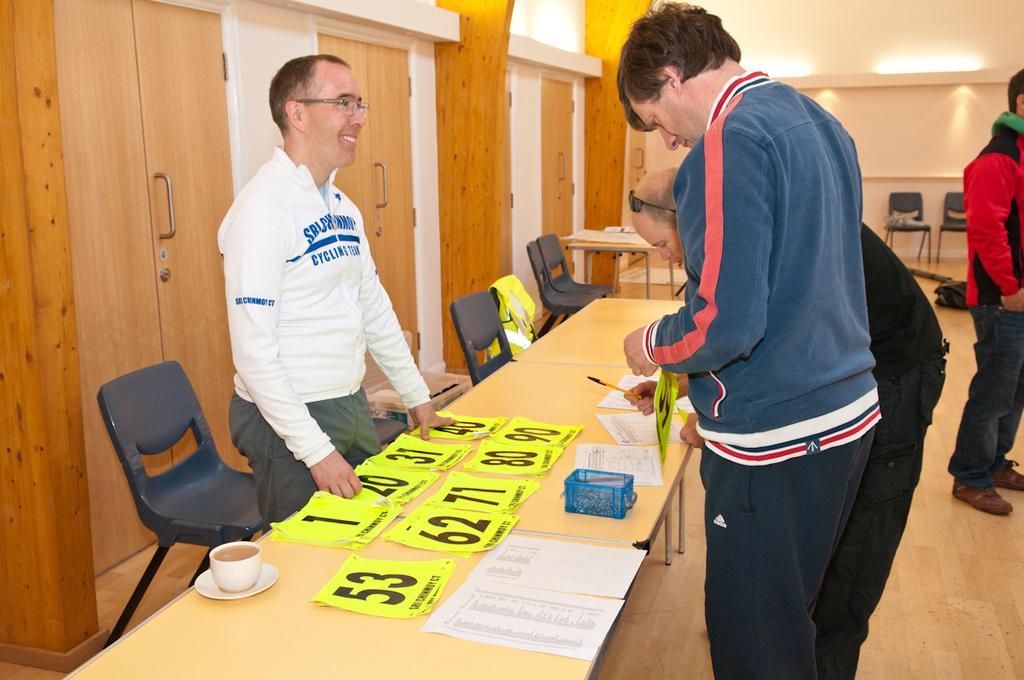In one or two sentences, can you explain what this image depicts? There are three people standing. this is the table. These are the green papers with numbers on it. This is a blue color object and cup and saucer placed on the table. these are the empty chairs. These are the doors with door handle. At the right side of the image I can see another person standing wearing red jerkin. I can see some green color object here. I think this is the bag on the floor. 